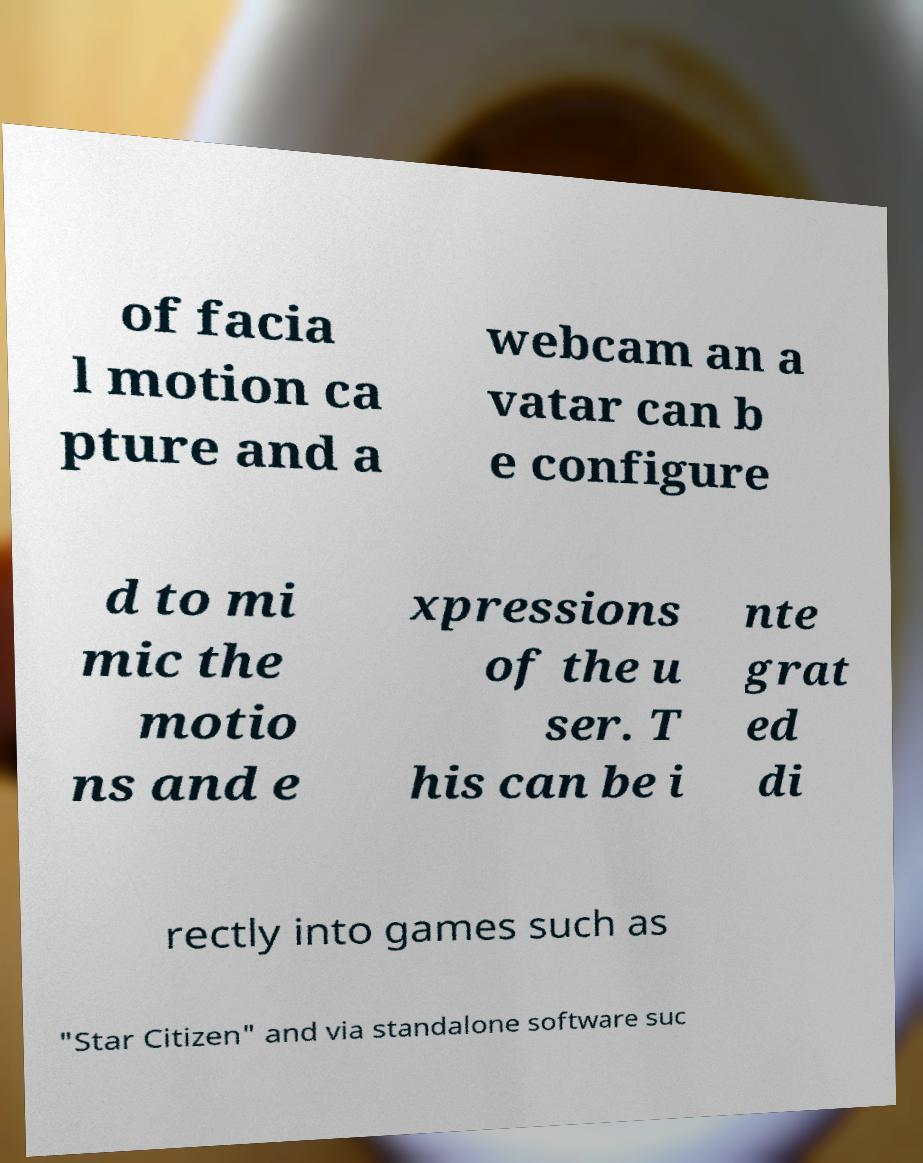Please read and relay the text visible in this image. What does it say? of facia l motion ca pture and a webcam an a vatar can b e configure d to mi mic the motio ns and e xpressions of the u ser. T his can be i nte grat ed di rectly into games such as "Star Citizen" and via standalone software suc 